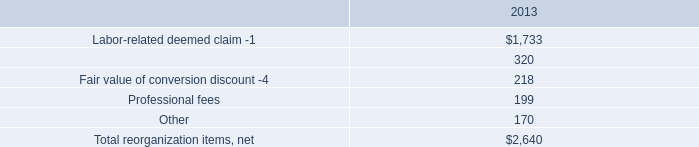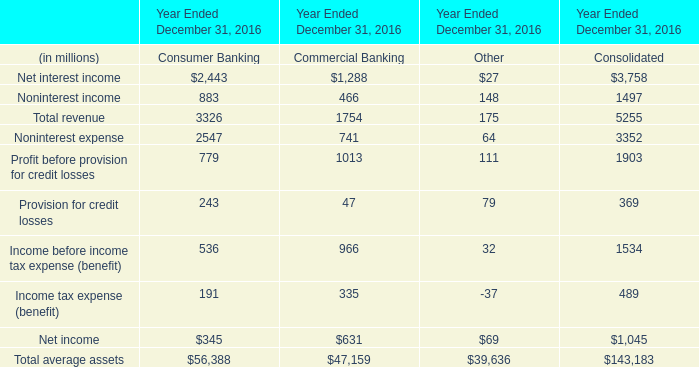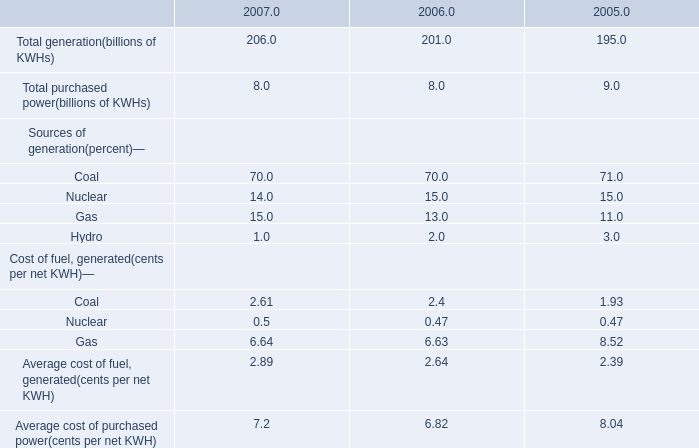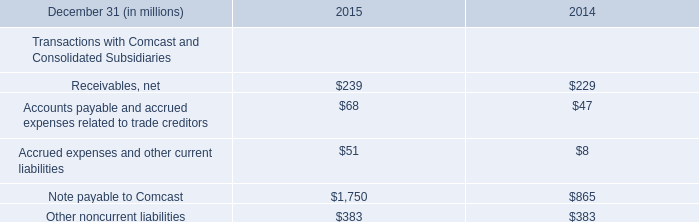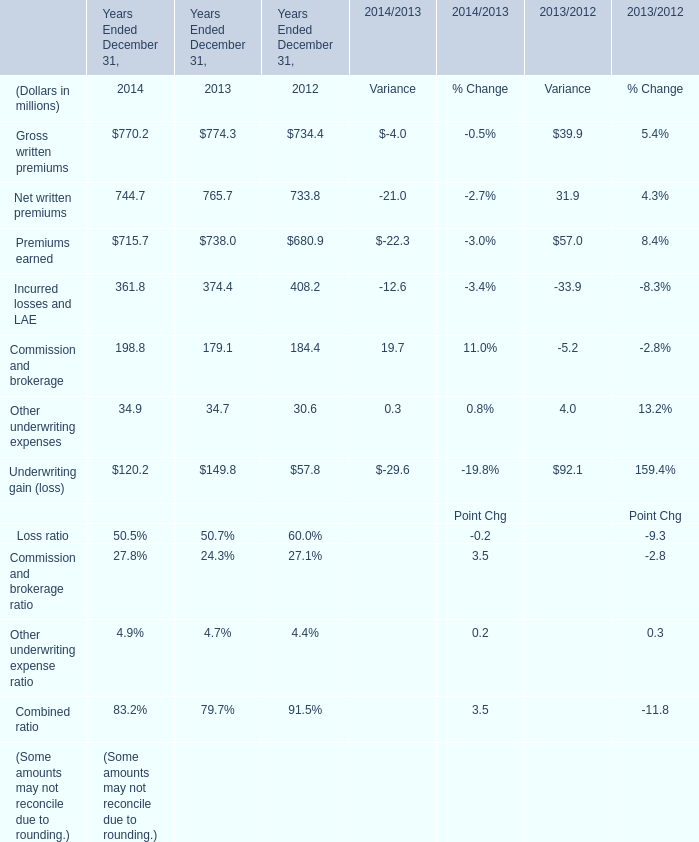What do all Noninterest income sum up, excluding those negative ones in 2016? (in million) 
Computations: ((883 + 466) + 148)
Answer: 1497.0. 